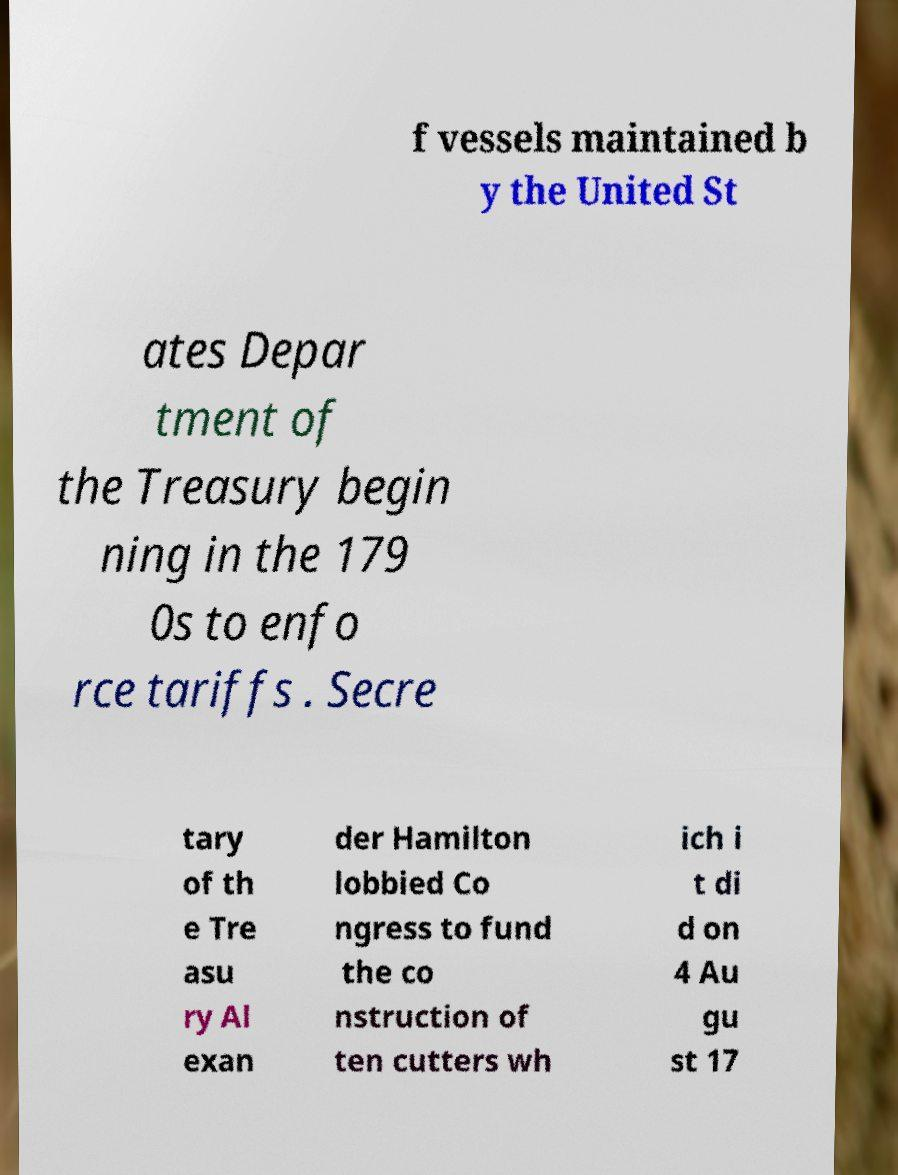For documentation purposes, I need the text within this image transcribed. Could you provide that? f vessels maintained b y the United St ates Depar tment of the Treasury begin ning in the 179 0s to enfo rce tariffs . Secre tary of th e Tre asu ry Al exan der Hamilton lobbied Co ngress to fund the co nstruction of ten cutters wh ich i t di d on 4 Au gu st 17 